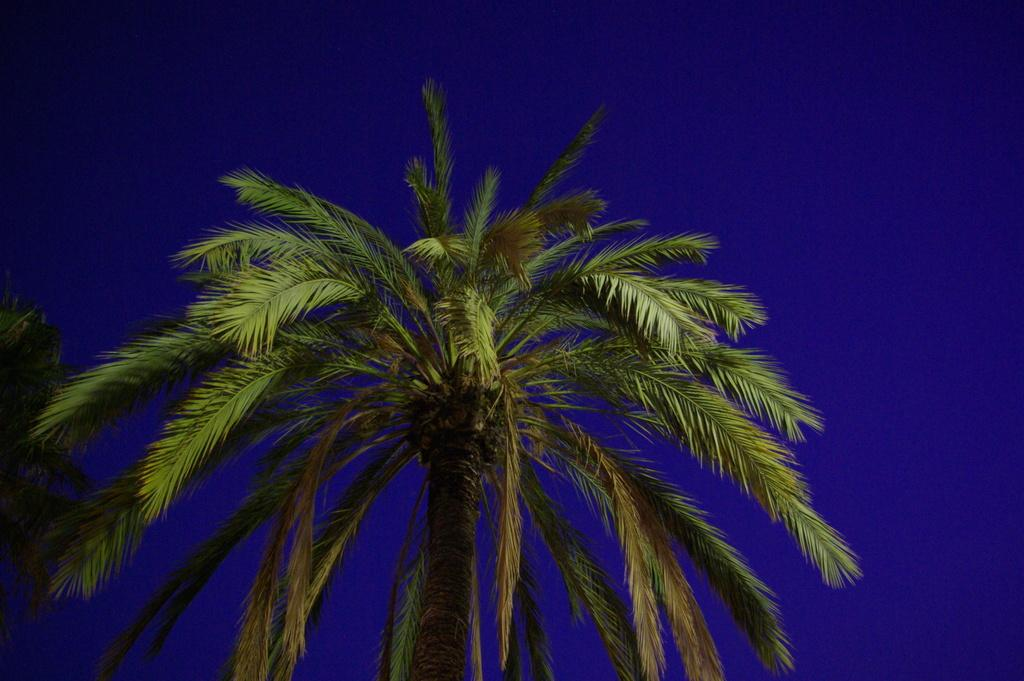What type of vegetation can be seen in the image? There are trees in the image. What is visible at the top of the image? The sky is visible at the top of the image. What is the condition of the sky in the image? The sky is clear in the image. What color is the sky in the image? The color of the sky is blue. Can you tell me how many zippers are visible in the image? There are no zippers present in the image. What type of machine can be seen operating in the image? There is no machine present in the image. 